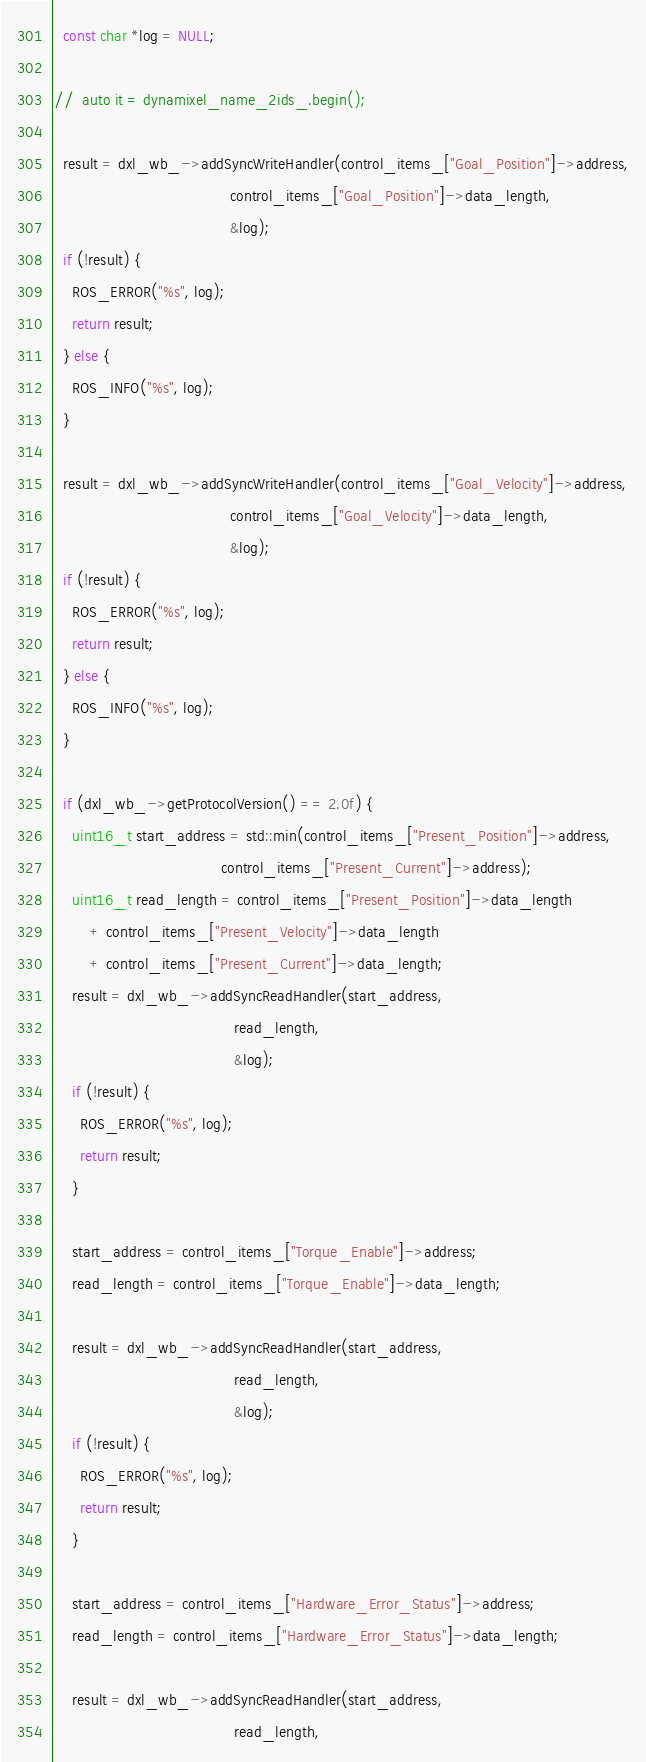<code> <loc_0><loc_0><loc_500><loc_500><_C++_>  const char *log = NULL;

//  auto it = dynamixel_name_2ids_.begin();

  result = dxl_wb_->addSyncWriteHandler(control_items_["Goal_Position"]->address,
                                        control_items_["Goal_Position"]->data_length,
                                        &log);
  if (!result) {
    ROS_ERROR("%s", log);
    return result;
  } else {
    ROS_INFO("%s", log);
  }

  result = dxl_wb_->addSyncWriteHandler(control_items_["Goal_Velocity"]->address,
                                        control_items_["Goal_Velocity"]->data_length,
                                        &log);
  if (!result) {
    ROS_ERROR("%s", log);
    return result;
  } else {
    ROS_INFO("%s", log);
  }

  if (dxl_wb_->getProtocolVersion() == 2.0f) {
    uint16_t start_address = std::min(control_items_["Present_Position"]->address,
                                      control_items_["Present_Current"]->address);
    uint16_t read_length = control_items_["Present_Position"]->data_length
        + control_items_["Present_Velocity"]->data_length
        + control_items_["Present_Current"]->data_length;
    result = dxl_wb_->addSyncReadHandler(start_address,
                                         read_length,
                                         &log);
    if (!result) {
      ROS_ERROR("%s", log);
      return result;
    }

    start_address = control_items_["Torque_Enable"]->address;
    read_length = control_items_["Torque_Enable"]->data_length;

    result = dxl_wb_->addSyncReadHandler(start_address,
                                         read_length,
                                         &log);
    if (!result) {
      ROS_ERROR("%s", log);
      return result;
    }

    start_address = control_items_["Hardware_Error_Status"]->address;
    read_length = control_items_["Hardware_Error_Status"]->data_length;

    result = dxl_wb_->addSyncReadHandler(start_address,
                                         read_length,</code> 